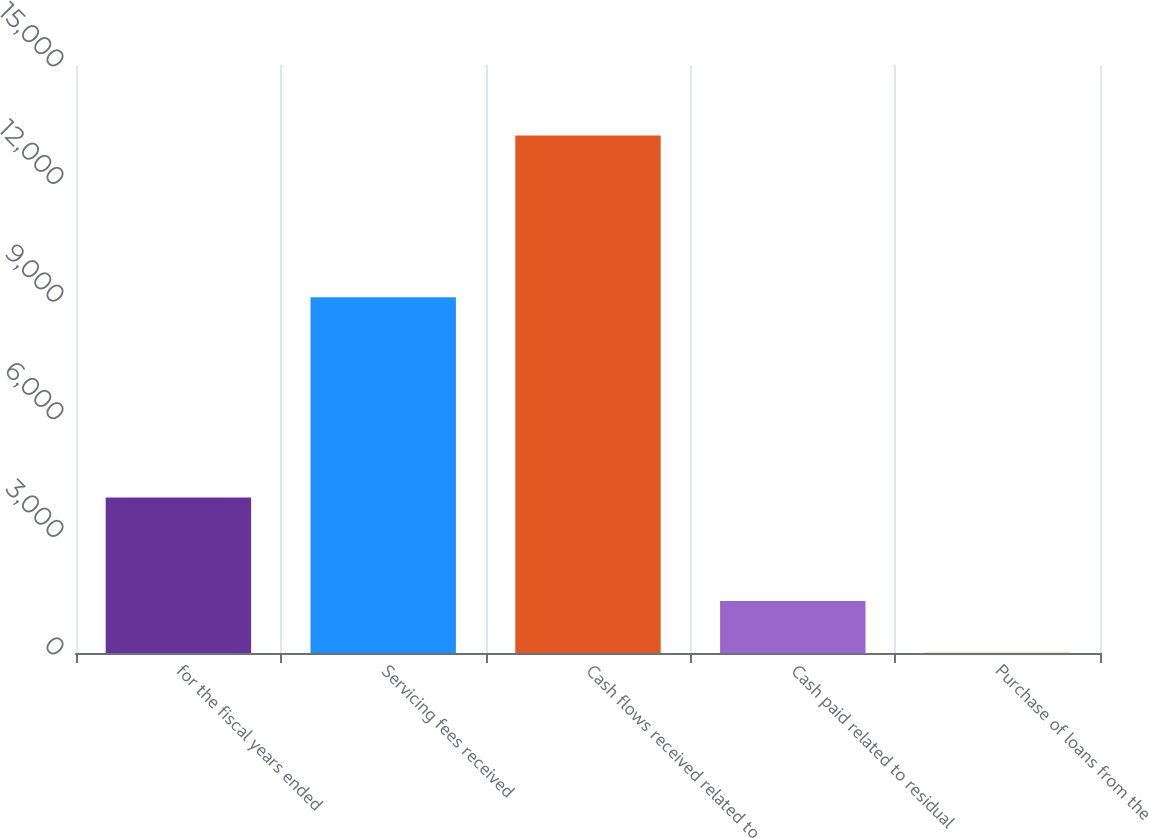Convert chart. <chart><loc_0><loc_0><loc_500><loc_500><bar_chart><fcel>for the fiscal years ended<fcel>Servicing fees received<fcel>Cash flows received related to<fcel>Cash paid related to residual<fcel>Purchase of loans from the<nl><fcel>3964.25<fcel>9078<fcel>13204<fcel>1324.32<fcel>4.35<nl></chart> 